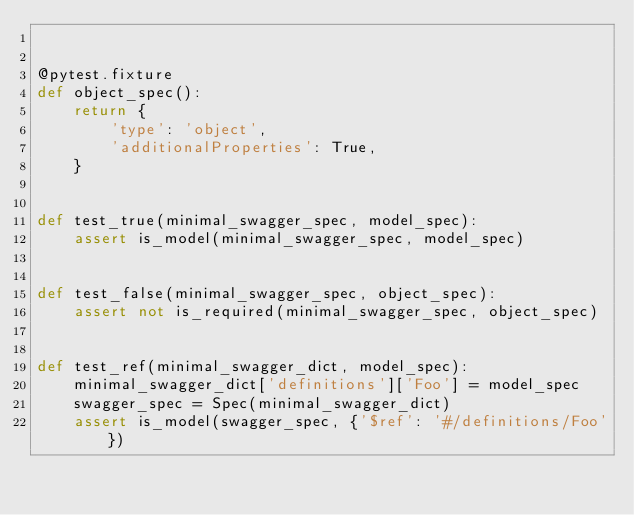<code> <loc_0><loc_0><loc_500><loc_500><_Python_>

@pytest.fixture
def object_spec():
    return {
        'type': 'object',
        'additionalProperties': True,
    }


def test_true(minimal_swagger_spec, model_spec):
    assert is_model(minimal_swagger_spec, model_spec)


def test_false(minimal_swagger_spec, object_spec):
    assert not is_required(minimal_swagger_spec, object_spec)


def test_ref(minimal_swagger_dict, model_spec):
    minimal_swagger_dict['definitions']['Foo'] = model_spec
    swagger_spec = Spec(minimal_swagger_dict)
    assert is_model(swagger_spec, {'$ref': '#/definitions/Foo'})
</code> 